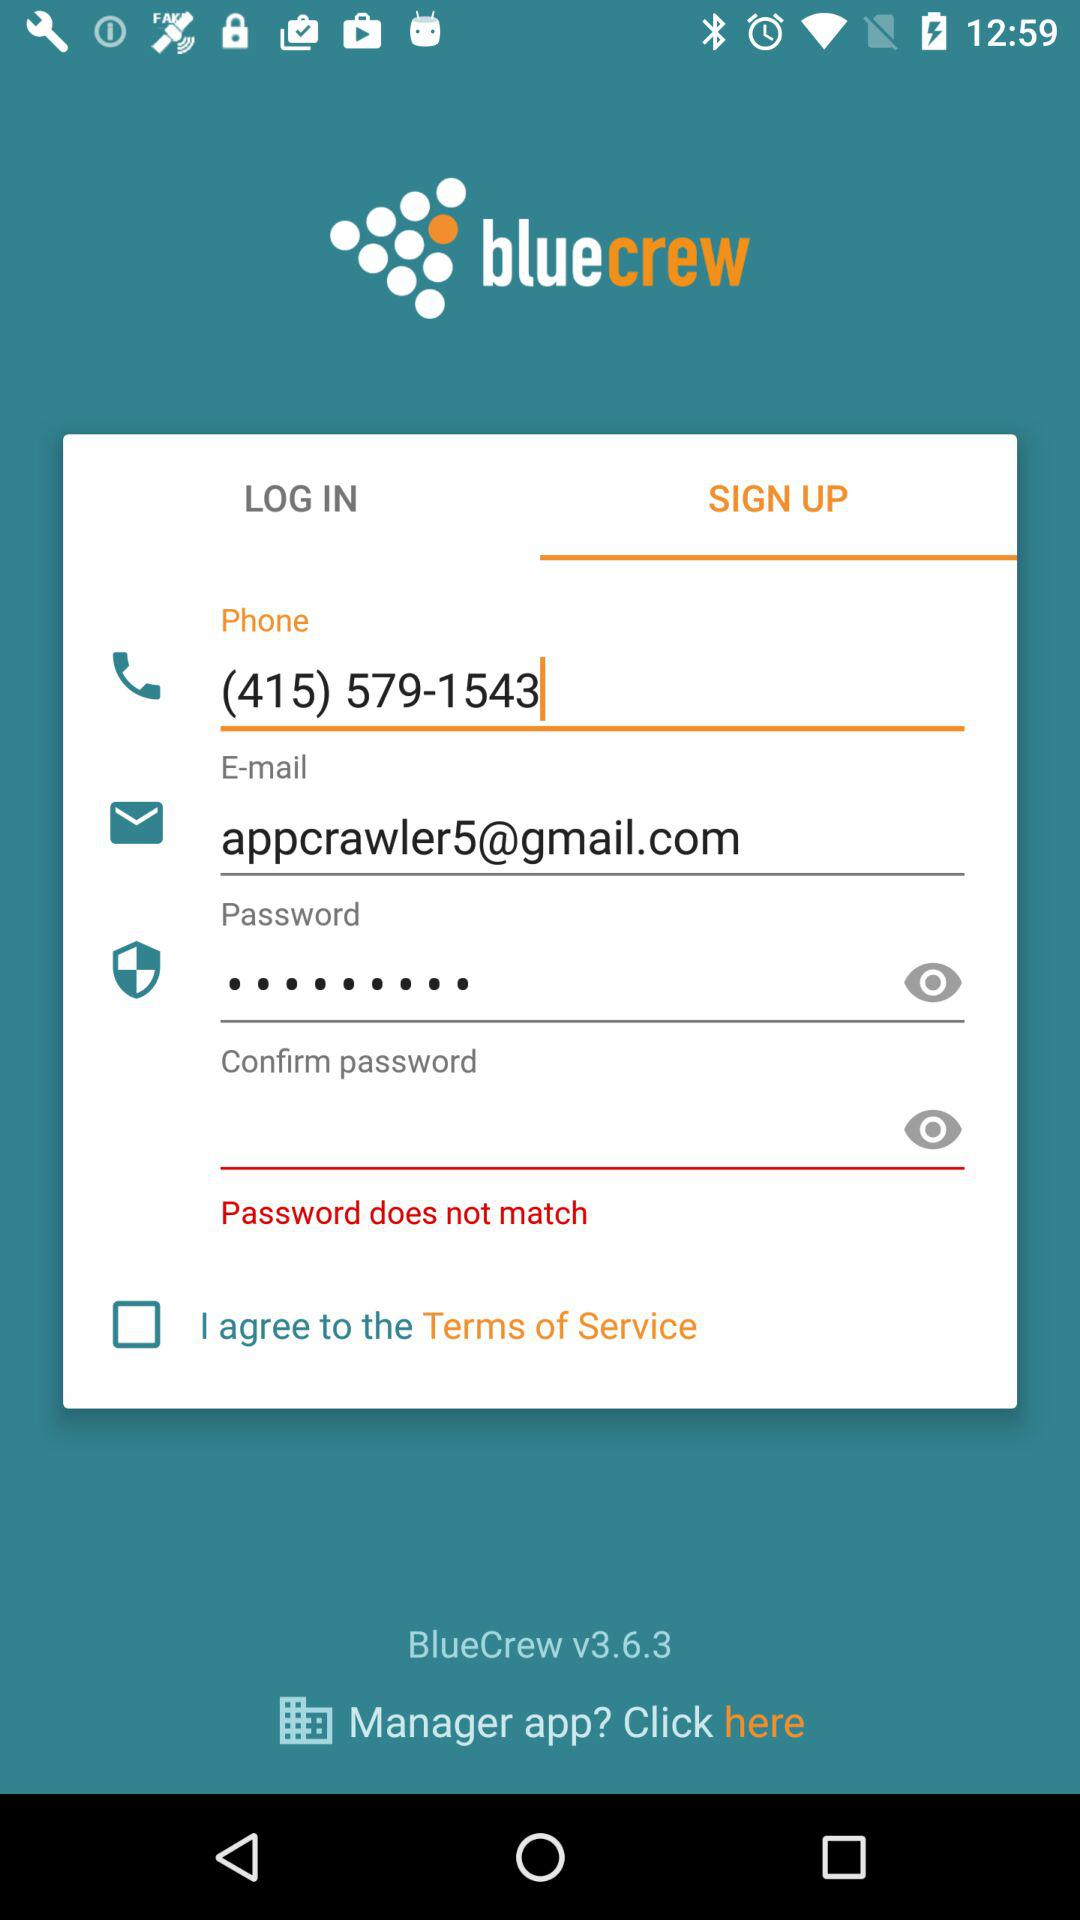What is the version of the app? The version of the app is v3.6.3. 